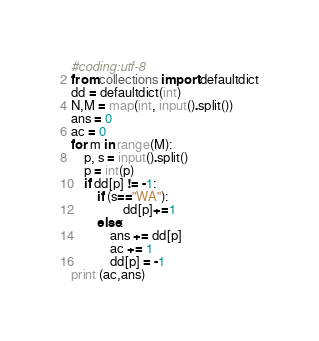<code> <loc_0><loc_0><loc_500><loc_500><_Python_>#coding:utf-8
from collections import defaultdict
dd = defaultdict(int)
N,M = map(int, input().split())
ans = 0
ac = 0
for m in range(M):
    p, s = input().split()
    p = int(p)
    if dd[p] != -1:
        if (s=="WA"):
                dd[p]+=1
        else:
            ans += dd[p]
            ac += 1
            dd[p] = -1
print (ac,ans)</code> 